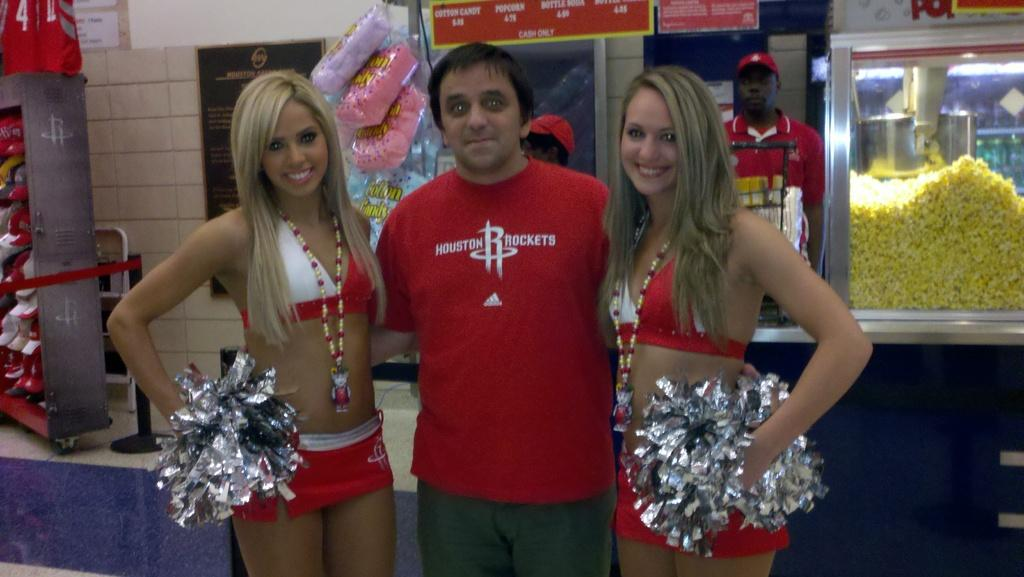<image>
Describe the image concisely. A man stands with two Houston Rockets cheerleaders. 